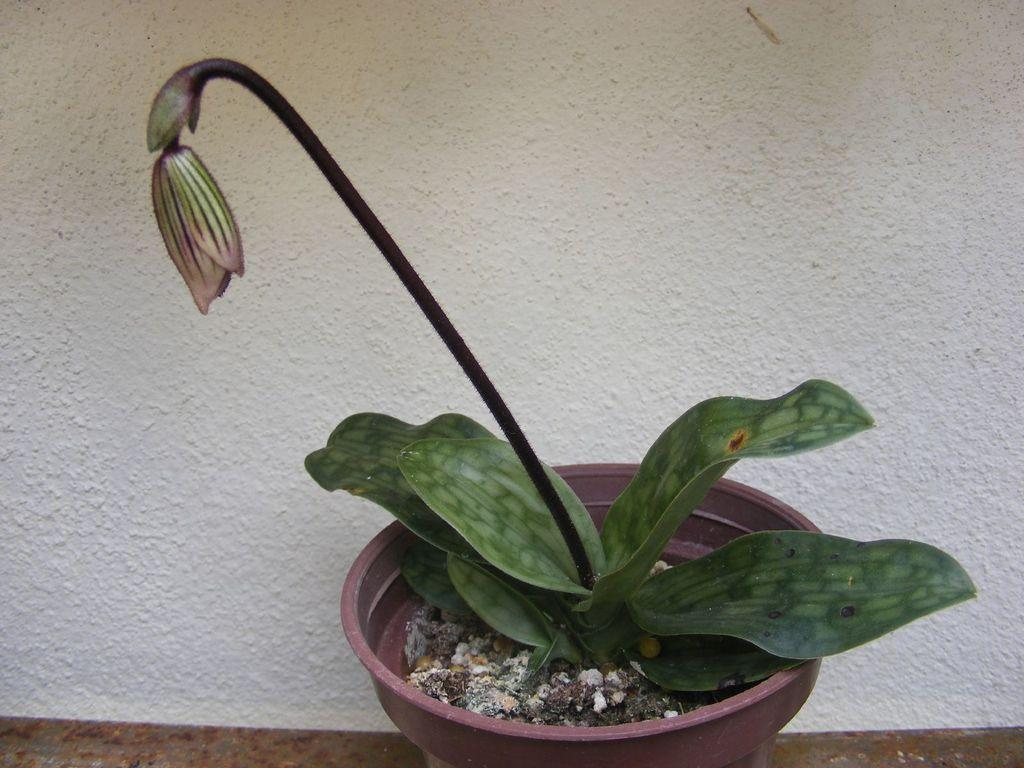What object is present in the image that holds plants? There is a flower pot in the image. What plant-related elements can be seen in the image? There are leaves and a bud visible in the image. What color is the background of the image? The background of the image is white. How many sparks can be seen in the image? There are no sparks present in the image. What type of cent is depicted in the image? There is no cent depicted in the image. 